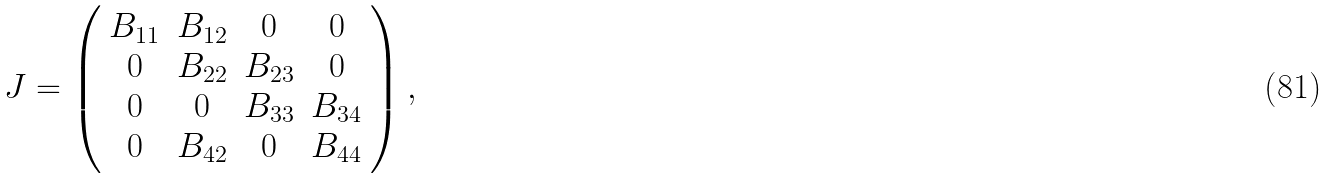Convert formula to latex. <formula><loc_0><loc_0><loc_500><loc_500>J = \left ( \begin{array} { c c c c } B _ { 1 1 } & B _ { 1 2 } & 0 & 0 \\ 0 & B _ { 2 2 } & B _ { 2 3 } & 0 \\ 0 & 0 & B _ { 3 3 } & B _ { 3 4 } \\ 0 & B _ { 4 2 } & 0 & B _ { 4 4 } \\ \end{array} \right ) ,</formula> 